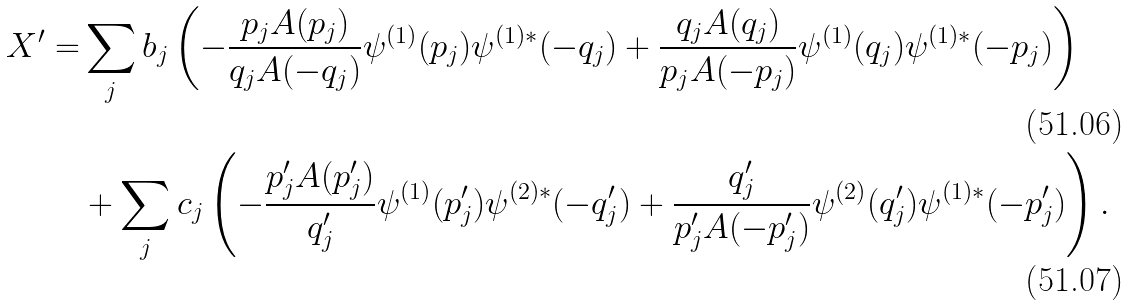<formula> <loc_0><loc_0><loc_500><loc_500>X ^ { \prime } = & \sum _ { j } b _ { j } \left ( - \frac { p _ { j } A ( p _ { j } ) } { q _ { j } A ( - q _ { j } ) } \psi ^ { ( 1 ) } ( p _ { j } ) \psi ^ { ( 1 ) \ast } ( - q _ { j } ) + \frac { q _ { j } A ( q _ { j } ) } { p _ { j } A ( - p _ { j } ) } \psi ^ { ( 1 ) } ( q _ { j } ) \psi ^ { ( 1 ) \ast } ( - p _ { j } ) \right ) \\ & + \sum _ { j } c _ { j } \left ( - \frac { p ^ { \prime } _ { j } A ( p ^ { \prime } _ { j } ) } { q ^ { \prime } _ { j } } \psi ^ { ( 1 ) } ( p ^ { \prime } _ { j } ) \psi ^ { ( 2 ) \ast } ( - q ^ { \prime } _ { j } ) + \frac { q ^ { \prime } _ { j } } { p ^ { \prime } _ { j } A ( - p ^ { \prime } _ { j } ) } \psi ^ { ( 2 ) } ( q ^ { \prime } _ { j } ) \psi ^ { ( 1 ) \ast } ( - p ^ { \prime } _ { j } ) \right ) .</formula> 